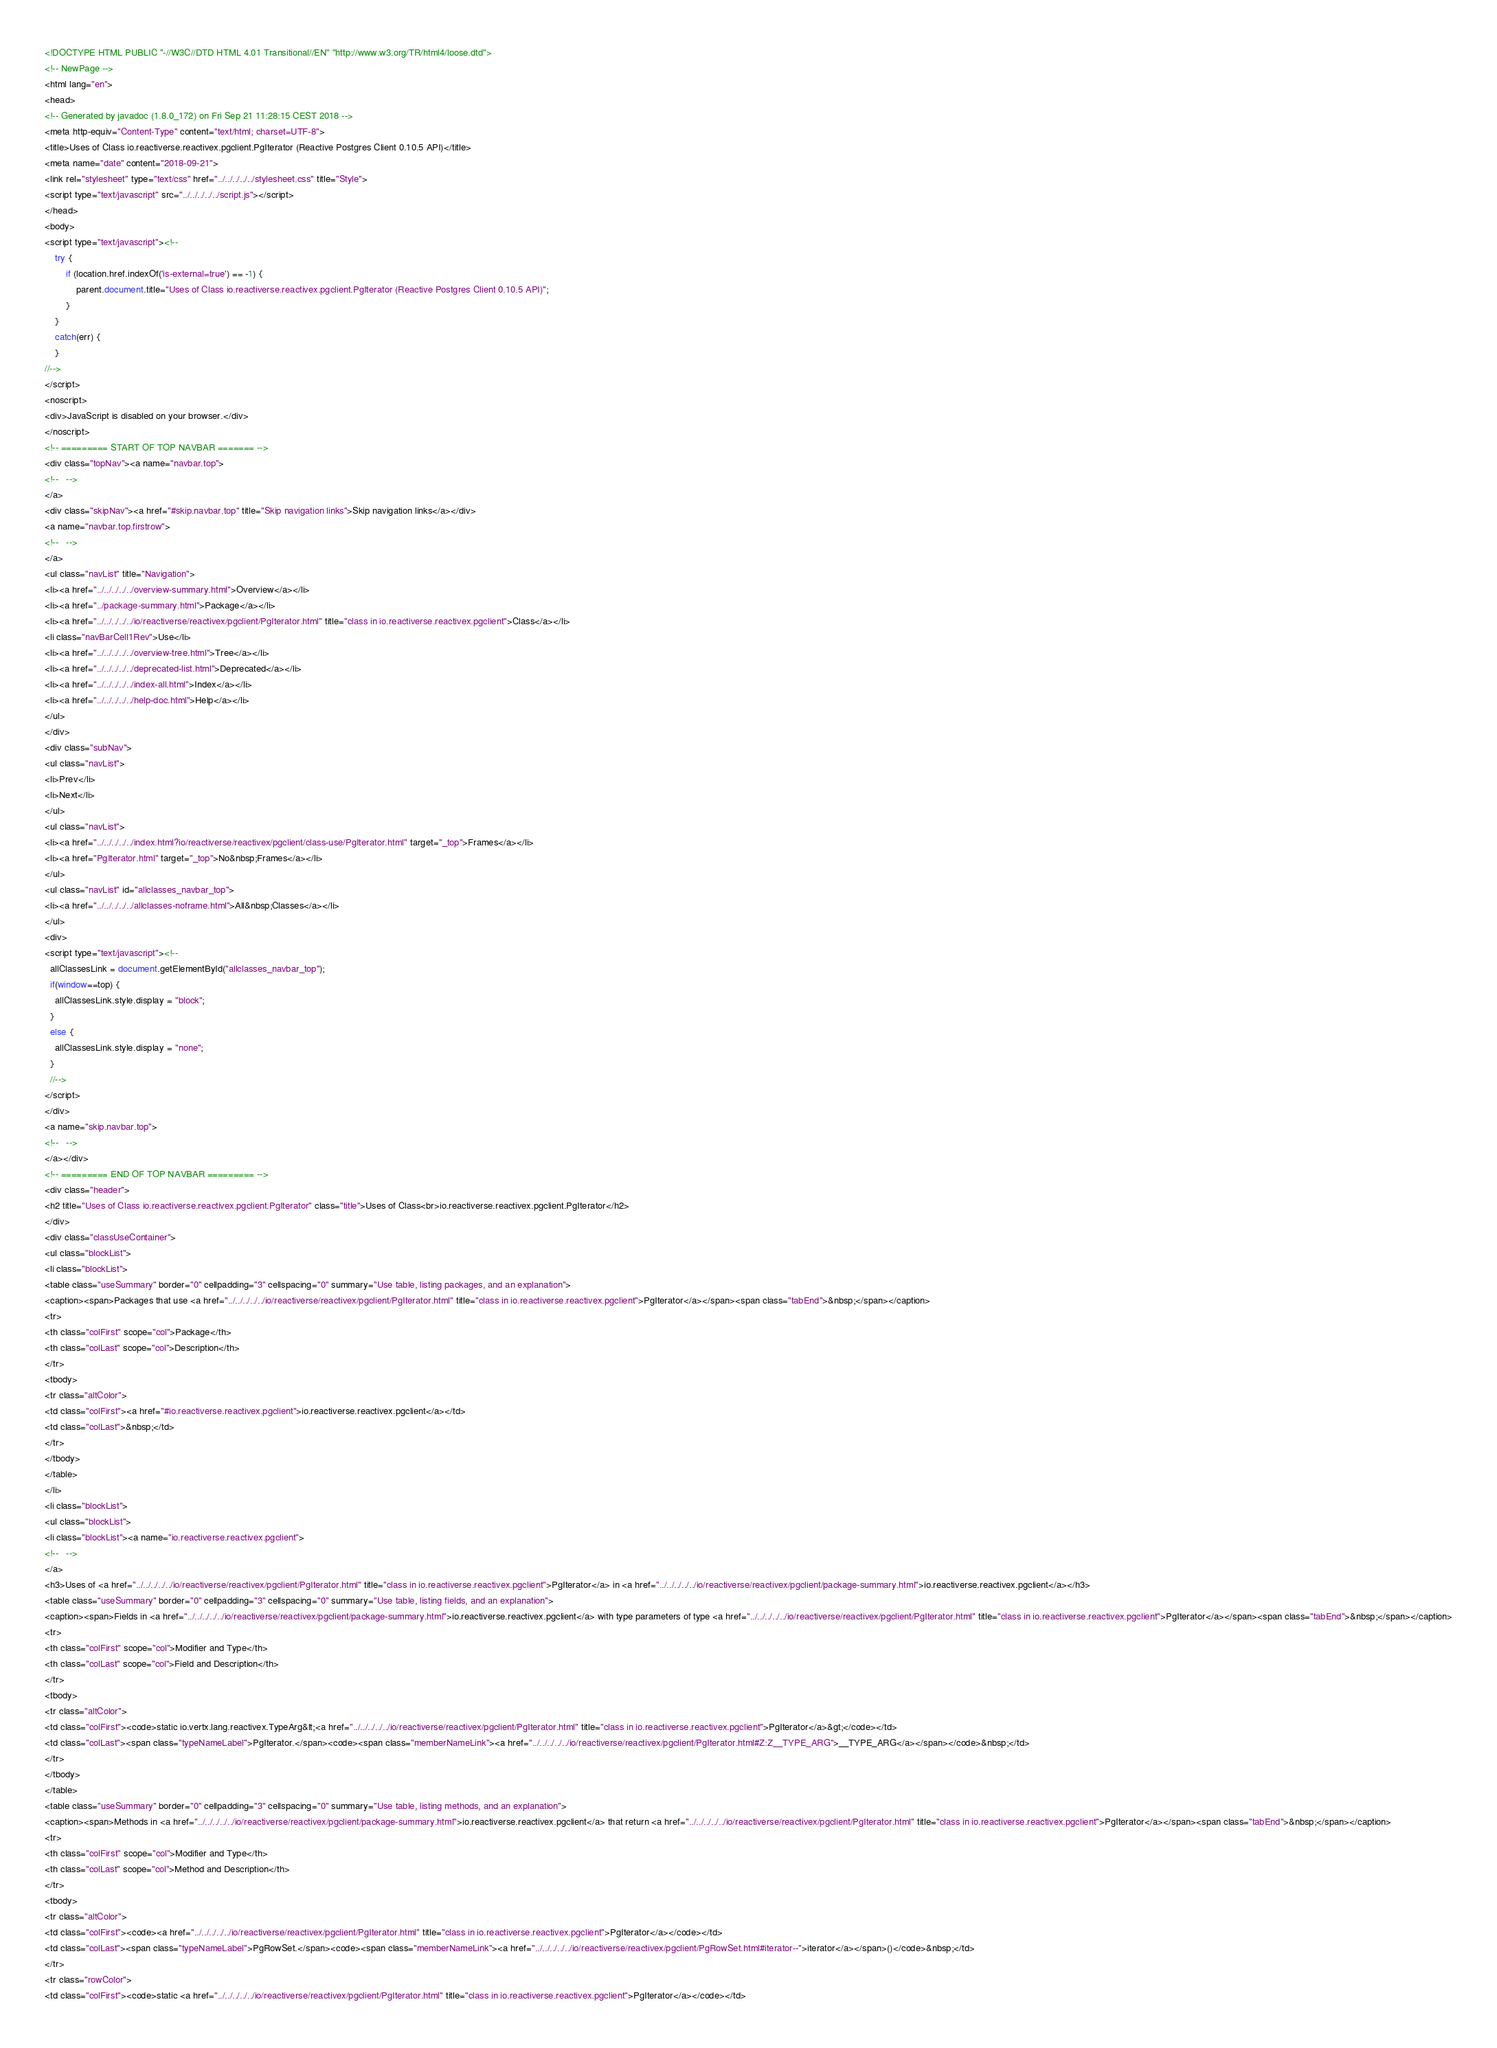<code> <loc_0><loc_0><loc_500><loc_500><_HTML_><!DOCTYPE HTML PUBLIC "-//W3C//DTD HTML 4.01 Transitional//EN" "http://www.w3.org/TR/html4/loose.dtd">
<!-- NewPage -->
<html lang="en">
<head>
<!-- Generated by javadoc (1.8.0_172) on Fri Sep 21 11:28:15 CEST 2018 -->
<meta http-equiv="Content-Type" content="text/html; charset=UTF-8">
<title>Uses of Class io.reactiverse.reactivex.pgclient.PgIterator (Reactive Postgres Client 0.10.5 API)</title>
<meta name="date" content="2018-09-21">
<link rel="stylesheet" type="text/css" href="../../../../../stylesheet.css" title="Style">
<script type="text/javascript" src="../../../../../script.js"></script>
</head>
<body>
<script type="text/javascript"><!--
    try {
        if (location.href.indexOf('is-external=true') == -1) {
            parent.document.title="Uses of Class io.reactiverse.reactivex.pgclient.PgIterator (Reactive Postgres Client 0.10.5 API)";
        }
    }
    catch(err) {
    }
//-->
</script>
<noscript>
<div>JavaScript is disabled on your browser.</div>
</noscript>
<!-- ========= START OF TOP NAVBAR ======= -->
<div class="topNav"><a name="navbar.top">
<!--   -->
</a>
<div class="skipNav"><a href="#skip.navbar.top" title="Skip navigation links">Skip navigation links</a></div>
<a name="navbar.top.firstrow">
<!--   -->
</a>
<ul class="navList" title="Navigation">
<li><a href="../../../../../overview-summary.html">Overview</a></li>
<li><a href="../package-summary.html">Package</a></li>
<li><a href="../../../../../io/reactiverse/reactivex/pgclient/PgIterator.html" title="class in io.reactiverse.reactivex.pgclient">Class</a></li>
<li class="navBarCell1Rev">Use</li>
<li><a href="../../../../../overview-tree.html">Tree</a></li>
<li><a href="../../../../../deprecated-list.html">Deprecated</a></li>
<li><a href="../../../../../index-all.html">Index</a></li>
<li><a href="../../../../../help-doc.html">Help</a></li>
</ul>
</div>
<div class="subNav">
<ul class="navList">
<li>Prev</li>
<li>Next</li>
</ul>
<ul class="navList">
<li><a href="../../../../../index.html?io/reactiverse/reactivex/pgclient/class-use/PgIterator.html" target="_top">Frames</a></li>
<li><a href="PgIterator.html" target="_top">No&nbsp;Frames</a></li>
</ul>
<ul class="navList" id="allclasses_navbar_top">
<li><a href="../../../../../allclasses-noframe.html">All&nbsp;Classes</a></li>
</ul>
<div>
<script type="text/javascript"><!--
  allClassesLink = document.getElementById("allclasses_navbar_top");
  if(window==top) {
    allClassesLink.style.display = "block";
  }
  else {
    allClassesLink.style.display = "none";
  }
  //-->
</script>
</div>
<a name="skip.navbar.top">
<!--   -->
</a></div>
<!-- ========= END OF TOP NAVBAR ========= -->
<div class="header">
<h2 title="Uses of Class io.reactiverse.reactivex.pgclient.PgIterator" class="title">Uses of Class<br>io.reactiverse.reactivex.pgclient.PgIterator</h2>
</div>
<div class="classUseContainer">
<ul class="blockList">
<li class="blockList">
<table class="useSummary" border="0" cellpadding="3" cellspacing="0" summary="Use table, listing packages, and an explanation">
<caption><span>Packages that use <a href="../../../../../io/reactiverse/reactivex/pgclient/PgIterator.html" title="class in io.reactiverse.reactivex.pgclient">PgIterator</a></span><span class="tabEnd">&nbsp;</span></caption>
<tr>
<th class="colFirst" scope="col">Package</th>
<th class="colLast" scope="col">Description</th>
</tr>
<tbody>
<tr class="altColor">
<td class="colFirst"><a href="#io.reactiverse.reactivex.pgclient">io.reactiverse.reactivex.pgclient</a></td>
<td class="colLast">&nbsp;</td>
</tr>
</tbody>
</table>
</li>
<li class="blockList">
<ul class="blockList">
<li class="blockList"><a name="io.reactiverse.reactivex.pgclient">
<!--   -->
</a>
<h3>Uses of <a href="../../../../../io/reactiverse/reactivex/pgclient/PgIterator.html" title="class in io.reactiverse.reactivex.pgclient">PgIterator</a> in <a href="../../../../../io/reactiverse/reactivex/pgclient/package-summary.html">io.reactiverse.reactivex.pgclient</a></h3>
<table class="useSummary" border="0" cellpadding="3" cellspacing="0" summary="Use table, listing fields, and an explanation">
<caption><span>Fields in <a href="../../../../../io/reactiverse/reactivex/pgclient/package-summary.html">io.reactiverse.reactivex.pgclient</a> with type parameters of type <a href="../../../../../io/reactiverse/reactivex/pgclient/PgIterator.html" title="class in io.reactiverse.reactivex.pgclient">PgIterator</a></span><span class="tabEnd">&nbsp;</span></caption>
<tr>
<th class="colFirst" scope="col">Modifier and Type</th>
<th class="colLast" scope="col">Field and Description</th>
</tr>
<tbody>
<tr class="altColor">
<td class="colFirst"><code>static io.vertx.lang.reactivex.TypeArg&lt;<a href="../../../../../io/reactiverse/reactivex/pgclient/PgIterator.html" title="class in io.reactiverse.reactivex.pgclient">PgIterator</a>&gt;</code></td>
<td class="colLast"><span class="typeNameLabel">PgIterator.</span><code><span class="memberNameLink"><a href="../../../../../io/reactiverse/reactivex/pgclient/PgIterator.html#Z:Z__TYPE_ARG">__TYPE_ARG</a></span></code>&nbsp;</td>
</tr>
</tbody>
</table>
<table class="useSummary" border="0" cellpadding="3" cellspacing="0" summary="Use table, listing methods, and an explanation">
<caption><span>Methods in <a href="../../../../../io/reactiverse/reactivex/pgclient/package-summary.html">io.reactiverse.reactivex.pgclient</a> that return <a href="../../../../../io/reactiverse/reactivex/pgclient/PgIterator.html" title="class in io.reactiverse.reactivex.pgclient">PgIterator</a></span><span class="tabEnd">&nbsp;</span></caption>
<tr>
<th class="colFirst" scope="col">Modifier and Type</th>
<th class="colLast" scope="col">Method and Description</th>
</tr>
<tbody>
<tr class="altColor">
<td class="colFirst"><code><a href="../../../../../io/reactiverse/reactivex/pgclient/PgIterator.html" title="class in io.reactiverse.reactivex.pgclient">PgIterator</a></code></td>
<td class="colLast"><span class="typeNameLabel">PgRowSet.</span><code><span class="memberNameLink"><a href="../../../../../io/reactiverse/reactivex/pgclient/PgRowSet.html#iterator--">iterator</a></span>()</code>&nbsp;</td>
</tr>
<tr class="rowColor">
<td class="colFirst"><code>static <a href="../../../../../io/reactiverse/reactivex/pgclient/PgIterator.html" title="class in io.reactiverse.reactivex.pgclient">PgIterator</a></code></td></code> 